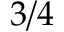<formula> <loc_0><loc_0><loc_500><loc_500>3 / 4</formula> 